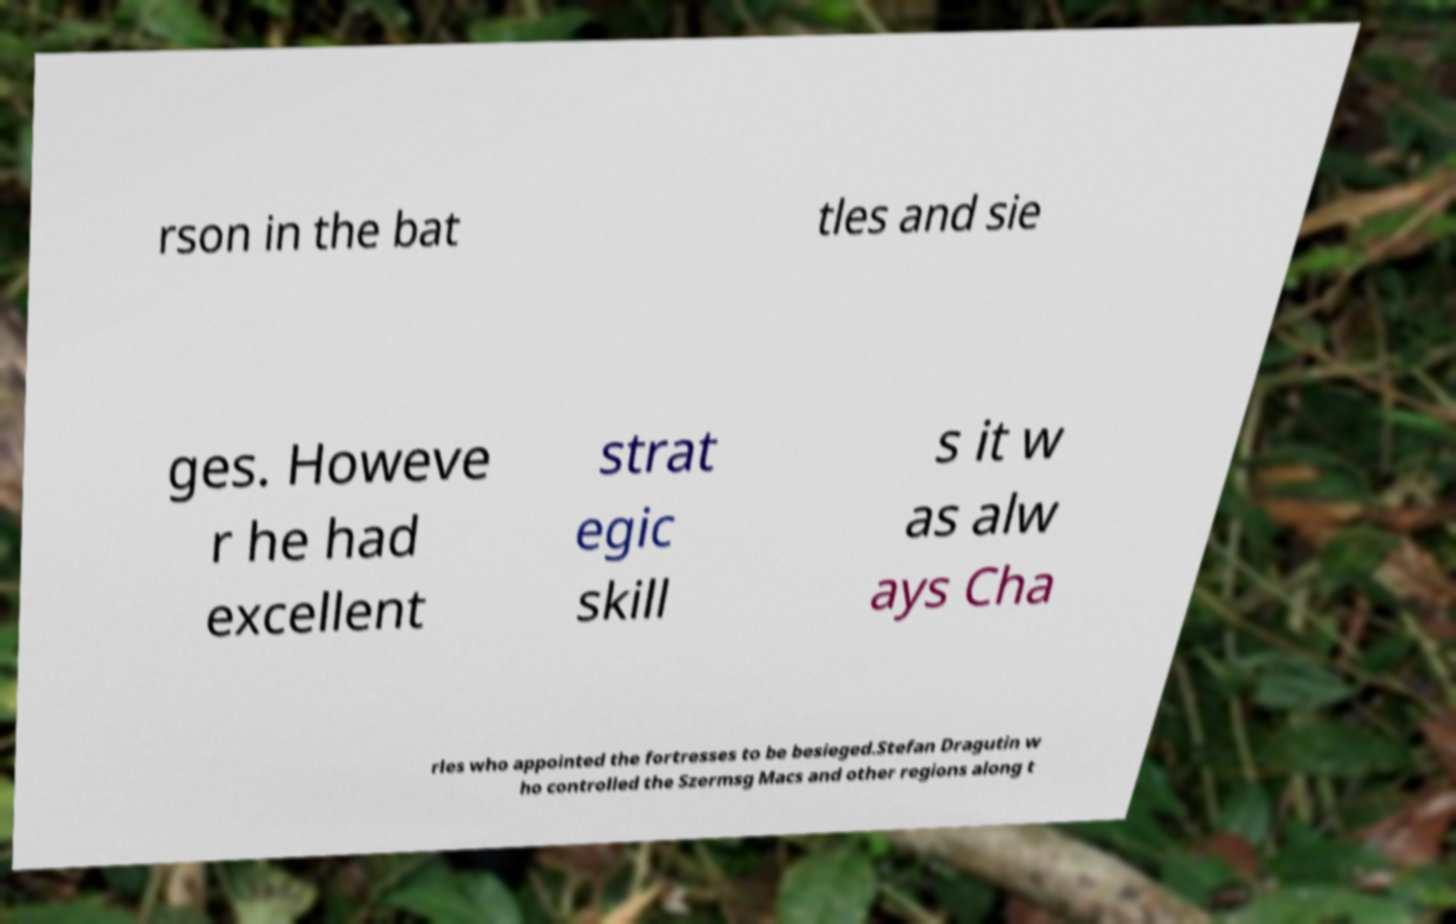Please identify and transcribe the text found in this image. rson in the bat tles and sie ges. Howeve r he had excellent strat egic skill s it w as alw ays Cha rles who appointed the fortresses to be besieged.Stefan Dragutin w ho controlled the Szermsg Macs and other regions along t 